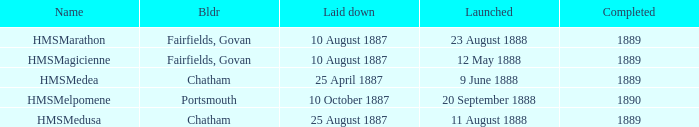When did chatham complete the Hmsmedusa? 1889.0. 